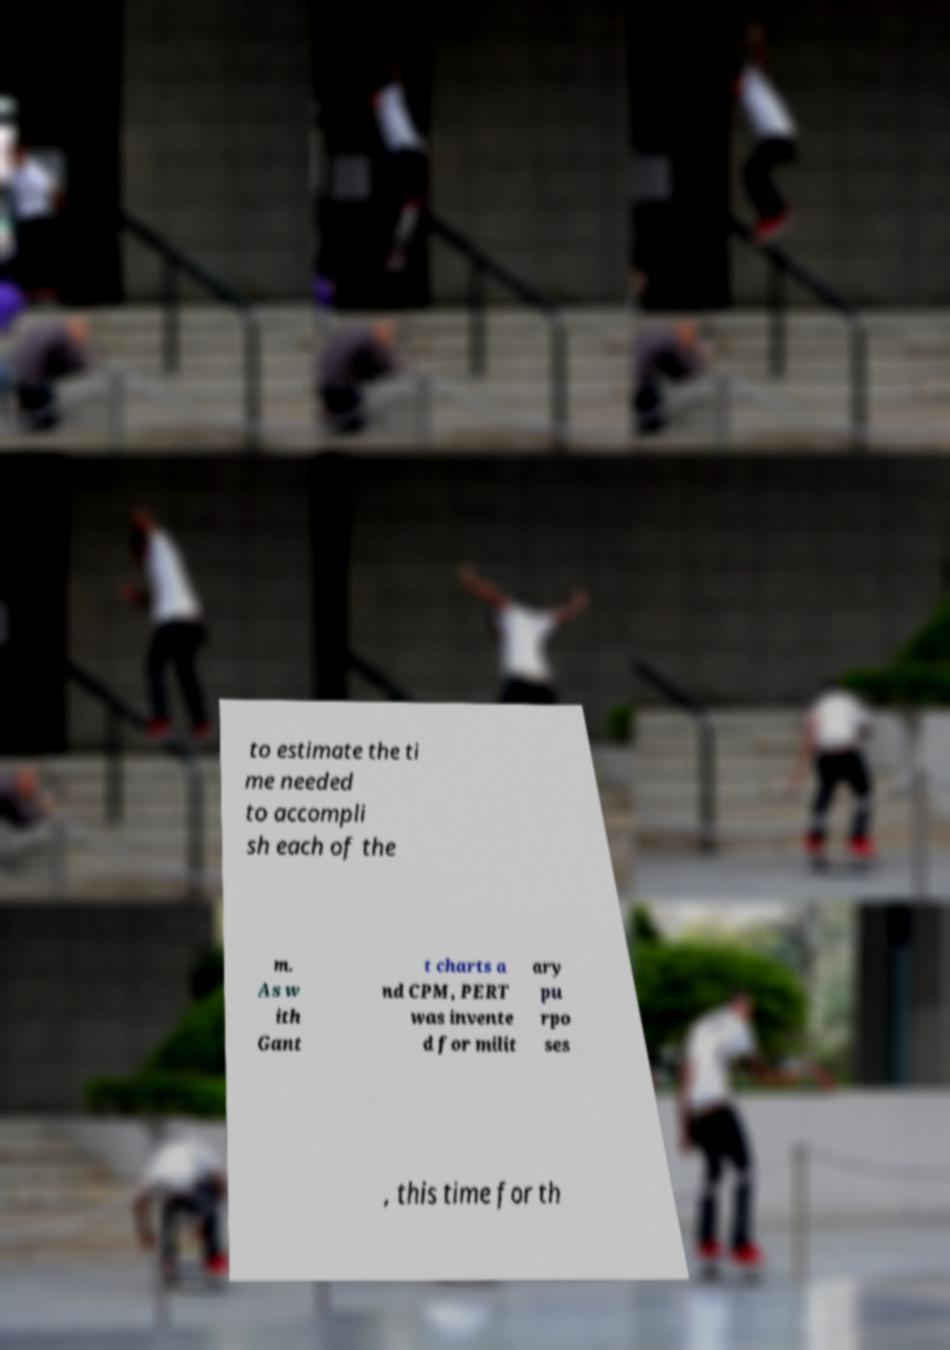Could you extract and type out the text from this image? to estimate the ti me needed to accompli sh each of the m. As w ith Gant t charts a nd CPM, PERT was invente d for milit ary pu rpo ses , this time for th 